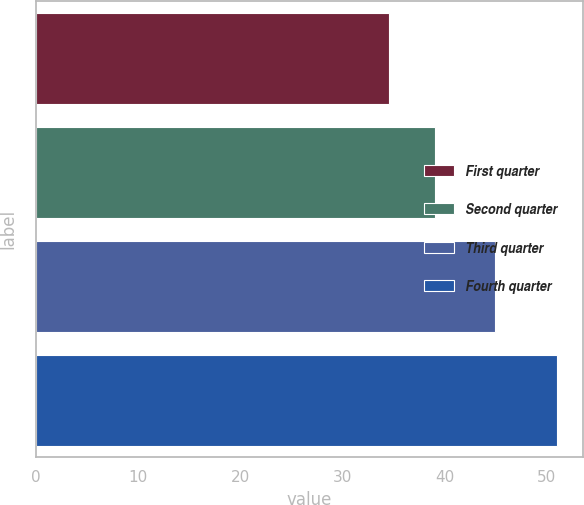Convert chart. <chart><loc_0><loc_0><loc_500><loc_500><bar_chart><fcel>First quarter<fcel>Second quarter<fcel>Third quarter<fcel>Fourth quarter<nl><fcel>34.58<fcel>39.05<fcel>44.94<fcel>50.97<nl></chart> 